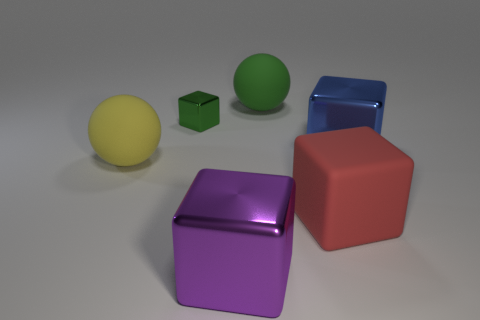Subtract all big purple blocks. How many blocks are left? 3 Add 1 large brown rubber cubes. How many objects exist? 7 Subtract all red blocks. How many blocks are left? 3 Subtract all cubes. How many objects are left? 2 Subtract 1 blocks. How many blocks are left? 3 Subtract all red matte cubes. Subtract all large blue shiny things. How many objects are left? 4 Add 1 large red rubber things. How many large red rubber things are left? 2 Add 4 purple cylinders. How many purple cylinders exist? 4 Subtract 0 blue balls. How many objects are left? 6 Subtract all yellow balls. Subtract all red cylinders. How many balls are left? 1 